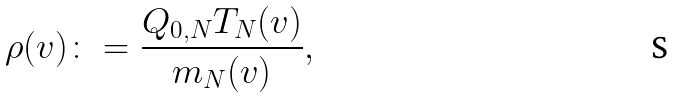Convert formula to latex. <formula><loc_0><loc_0><loc_500><loc_500>\rho ( v ) \colon = \frac { Q _ { 0 , N } T _ { N } ( v ) } { m _ { N } ( v ) } ,</formula> 